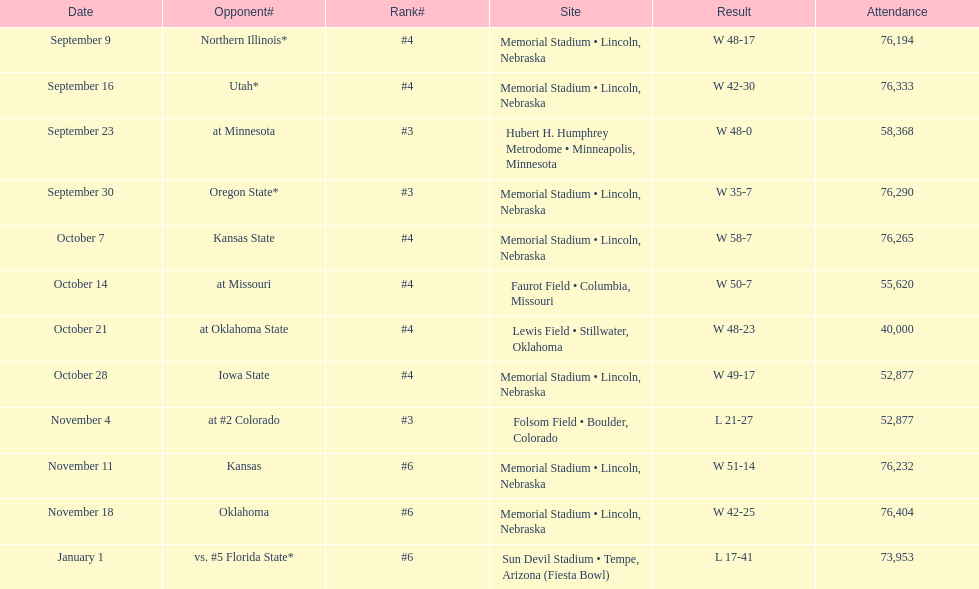How many games did they win by more than 7? 10. 